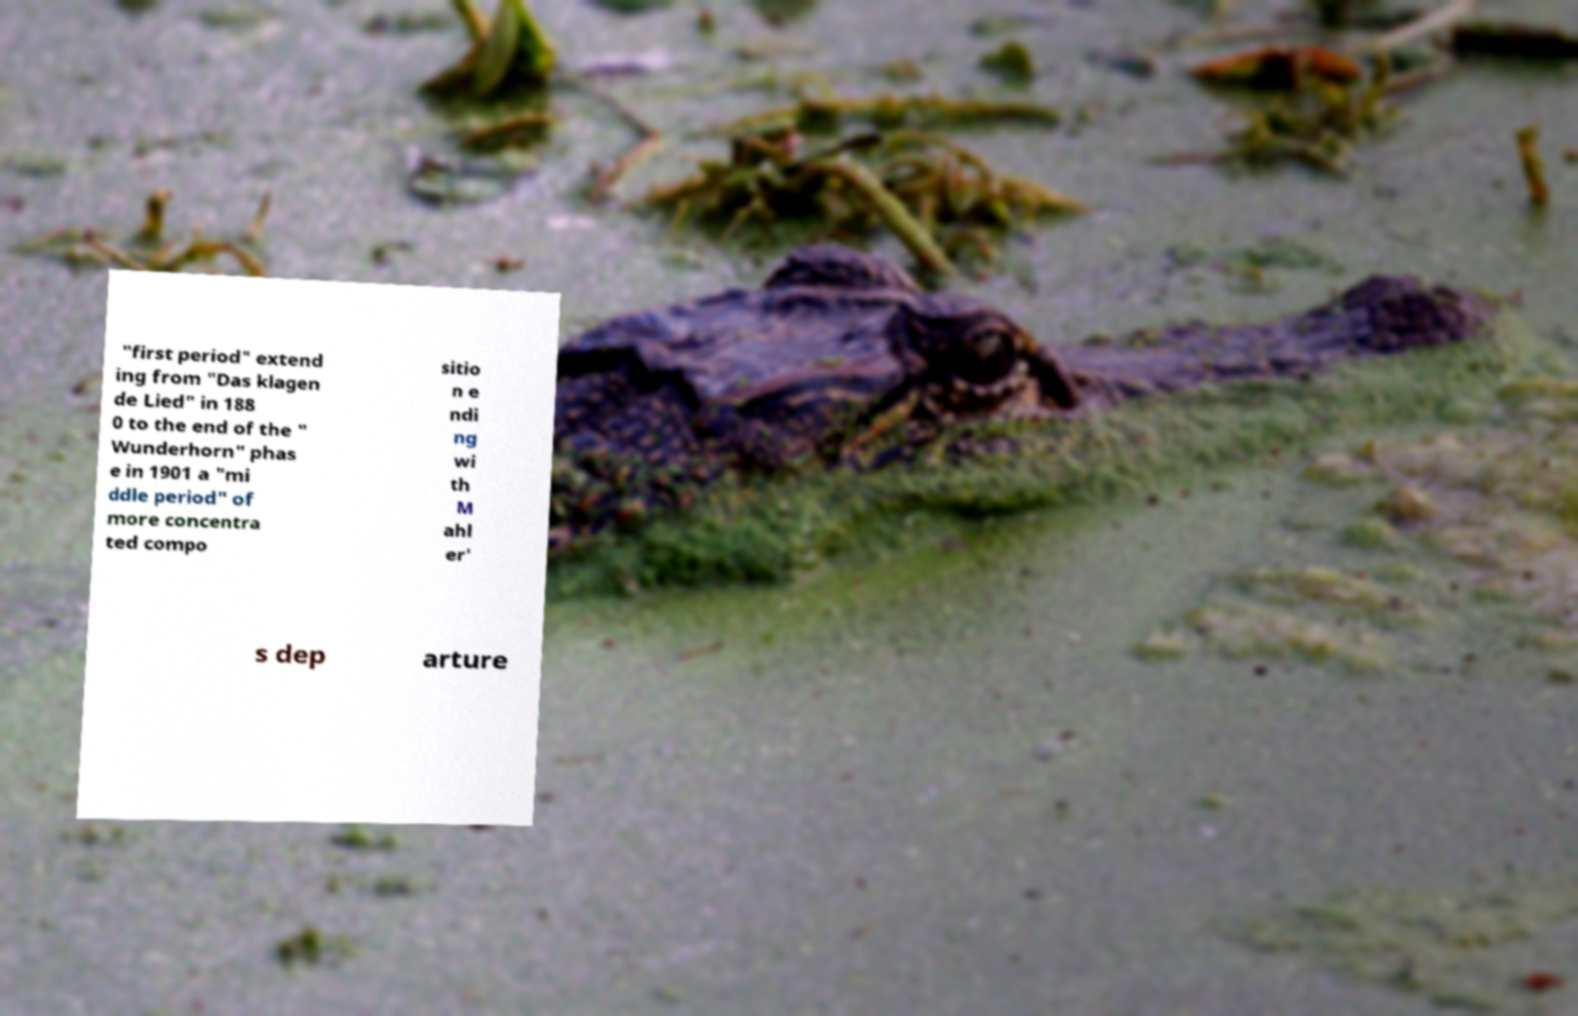Please identify and transcribe the text found in this image. "first period" extend ing from "Das klagen de Lied" in 188 0 to the end of the " Wunderhorn" phas e in 1901 a "mi ddle period" of more concentra ted compo sitio n e ndi ng wi th M ahl er' s dep arture 